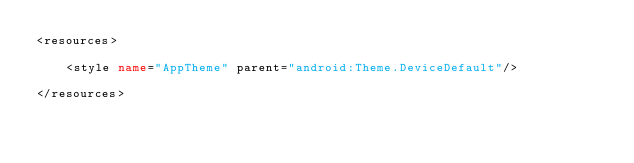Convert code to text. <code><loc_0><loc_0><loc_500><loc_500><_XML_><resources>

    <style name="AppTheme" parent="android:Theme.DeviceDefault"/>

</resources>
</code> 